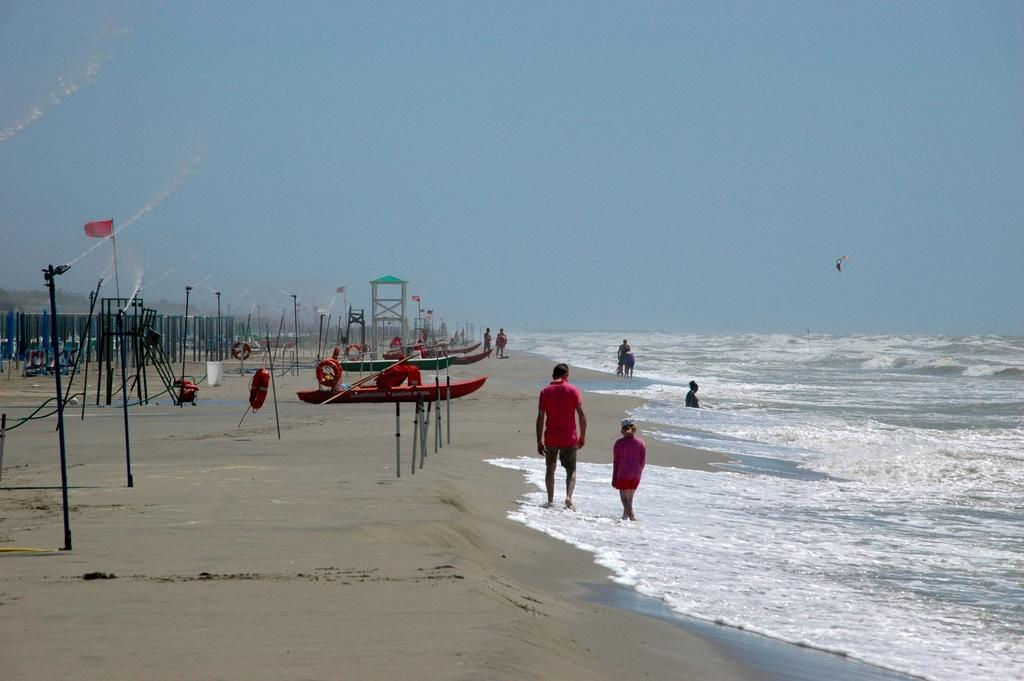What type of objects can be seen in the image? There are poles, flags, boats, swim tubes, and objects on the sand in the image. What is attached to the poles in the image? Flags are attached to the poles in the image. What type of water activity is associated with the swim tubes? Swim tubes are typically used for floating or playing in the water. What can be seen on the sand in the image? There are objects on the sand in the image. Are there any people present in the image? Yes, there are people in the image. What type of environment is visible in the image? There is water and sand visible in the image, as well as the sky in the background. How many spiders are crawling on the boats in the image? There are no spiders visible in the image; it features boats, poles, flags, swim tubes, and people. What type of bait is being used by the people in the image? There is no indication of fishing or bait in the image; it primarily focuses on boats, poles, flags, swim tubes, and people. 